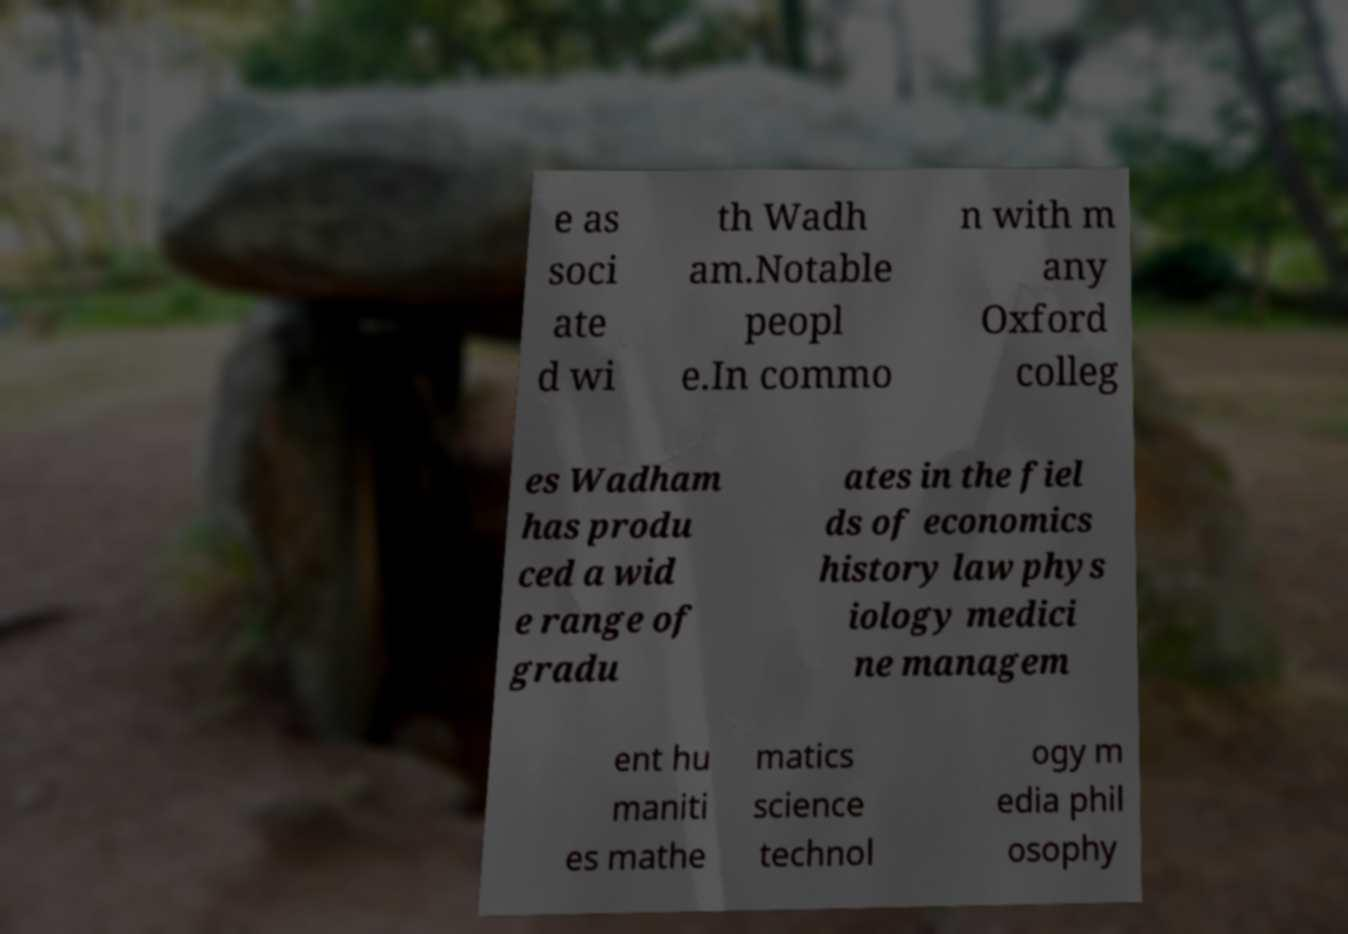Can you accurately transcribe the text from the provided image for me? e as soci ate d wi th Wadh am.Notable peopl e.In commo n with m any Oxford colleg es Wadham has produ ced a wid e range of gradu ates in the fiel ds of economics history law phys iology medici ne managem ent hu maniti es mathe matics science technol ogy m edia phil osophy 